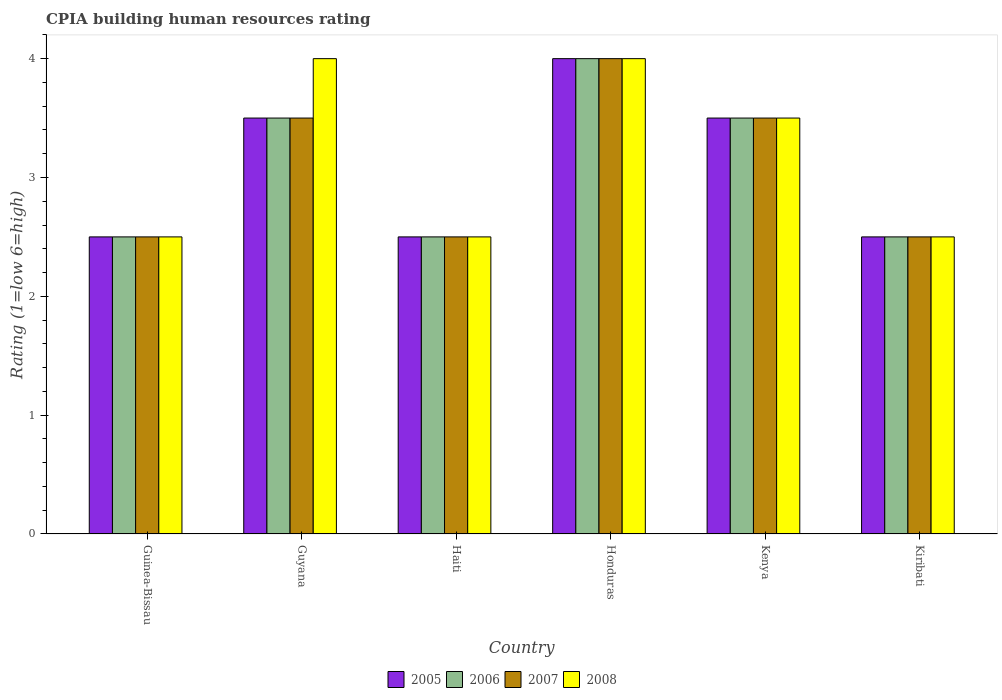How many different coloured bars are there?
Offer a terse response. 4. Are the number of bars per tick equal to the number of legend labels?
Your answer should be compact. Yes. How many bars are there on the 4th tick from the left?
Offer a terse response. 4. How many bars are there on the 5th tick from the right?
Ensure brevity in your answer.  4. What is the label of the 5th group of bars from the left?
Your response must be concise. Kenya. In how many cases, is the number of bars for a given country not equal to the number of legend labels?
Make the answer very short. 0. What is the CPIA rating in 2007 in Guyana?
Provide a succinct answer. 3.5. In which country was the CPIA rating in 2006 maximum?
Your response must be concise. Honduras. In which country was the CPIA rating in 2008 minimum?
Ensure brevity in your answer.  Guinea-Bissau. What is the difference between the CPIA rating in 2008 in Guyana and that in Kiribati?
Offer a very short reply. 1.5. What is the average CPIA rating in 2006 per country?
Ensure brevity in your answer.  3.08. What is the difference between the CPIA rating of/in 2005 and CPIA rating of/in 2007 in Honduras?
Give a very brief answer. 0. What is the ratio of the CPIA rating in 2006 in Guinea-Bissau to that in Haiti?
Offer a terse response. 1. Is the CPIA rating in 2008 in Honduras less than that in Kiribati?
Your response must be concise. No. Is the difference between the CPIA rating in 2005 in Guinea-Bissau and Honduras greater than the difference between the CPIA rating in 2007 in Guinea-Bissau and Honduras?
Offer a terse response. No. What is the difference between the highest and the second highest CPIA rating in 2007?
Give a very brief answer. -0.5. In how many countries, is the CPIA rating in 2008 greater than the average CPIA rating in 2008 taken over all countries?
Make the answer very short. 3. Is the sum of the CPIA rating in 2006 in Kenya and Kiribati greater than the maximum CPIA rating in 2005 across all countries?
Ensure brevity in your answer.  Yes. Is it the case that in every country, the sum of the CPIA rating in 2007 and CPIA rating in 2006 is greater than the sum of CPIA rating in 2005 and CPIA rating in 2008?
Keep it short and to the point. No. What does the 1st bar from the right in Haiti represents?
Make the answer very short. 2008. How many bars are there?
Your response must be concise. 24. Are all the bars in the graph horizontal?
Your response must be concise. No. What is the difference between two consecutive major ticks on the Y-axis?
Offer a very short reply. 1. Are the values on the major ticks of Y-axis written in scientific E-notation?
Offer a terse response. No. Does the graph contain grids?
Make the answer very short. No. Where does the legend appear in the graph?
Your response must be concise. Bottom center. What is the title of the graph?
Make the answer very short. CPIA building human resources rating. What is the label or title of the Y-axis?
Your response must be concise. Rating (1=low 6=high). What is the Rating (1=low 6=high) of 2005 in Guinea-Bissau?
Make the answer very short. 2.5. What is the Rating (1=low 6=high) of 2006 in Guinea-Bissau?
Provide a short and direct response. 2.5. What is the Rating (1=low 6=high) in 2007 in Guinea-Bissau?
Ensure brevity in your answer.  2.5. What is the Rating (1=low 6=high) of 2008 in Guinea-Bissau?
Offer a very short reply. 2.5. What is the Rating (1=low 6=high) in 2005 in Guyana?
Offer a terse response. 3.5. What is the Rating (1=low 6=high) of 2006 in Guyana?
Your response must be concise. 3.5. What is the Rating (1=low 6=high) of 2005 in Haiti?
Your answer should be compact. 2.5. What is the Rating (1=low 6=high) in 2007 in Honduras?
Provide a short and direct response. 4. What is the Rating (1=low 6=high) of 2008 in Honduras?
Keep it short and to the point. 4. What is the Rating (1=low 6=high) of 2005 in Kenya?
Give a very brief answer. 3.5. What is the Rating (1=low 6=high) in 2007 in Kenya?
Give a very brief answer. 3.5. What is the Rating (1=low 6=high) of 2005 in Kiribati?
Give a very brief answer. 2.5. Across all countries, what is the maximum Rating (1=low 6=high) in 2005?
Provide a short and direct response. 4. Across all countries, what is the minimum Rating (1=low 6=high) in 2005?
Offer a very short reply. 2.5. Across all countries, what is the minimum Rating (1=low 6=high) in 2007?
Your answer should be very brief. 2.5. What is the total Rating (1=low 6=high) in 2005 in the graph?
Provide a short and direct response. 18.5. What is the total Rating (1=low 6=high) in 2008 in the graph?
Offer a very short reply. 19. What is the difference between the Rating (1=low 6=high) of 2006 in Guinea-Bissau and that in Guyana?
Offer a very short reply. -1. What is the difference between the Rating (1=low 6=high) in 2008 in Guinea-Bissau and that in Guyana?
Ensure brevity in your answer.  -1.5. What is the difference between the Rating (1=low 6=high) in 2008 in Guinea-Bissau and that in Haiti?
Provide a succinct answer. 0. What is the difference between the Rating (1=low 6=high) of 2006 in Guinea-Bissau and that in Honduras?
Make the answer very short. -1.5. What is the difference between the Rating (1=low 6=high) of 2006 in Guinea-Bissau and that in Kenya?
Provide a short and direct response. -1. What is the difference between the Rating (1=low 6=high) of 2007 in Guinea-Bissau and that in Kenya?
Ensure brevity in your answer.  -1. What is the difference between the Rating (1=low 6=high) of 2008 in Guinea-Bissau and that in Kenya?
Make the answer very short. -1. What is the difference between the Rating (1=low 6=high) of 2005 in Guinea-Bissau and that in Kiribati?
Give a very brief answer. 0. What is the difference between the Rating (1=low 6=high) of 2006 in Guinea-Bissau and that in Kiribati?
Your answer should be compact. 0. What is the difference between the Rating (1=low 6=high) in 2006 in Guyana and that in Haiti?
Offer a very short reply. 1. What is the difference between the Rating (1=low 6=high) of 2007 in Guyana and that in Haiti?
Provide a short and direct response. 1. What is the difference between the Rating (1=low 6=high) of 2008 in Guyana and that in Haiti?
Offer a terse response. 1.5. What is the difference between the Rating (1=low 6=high) of 2005 in Guyana and that in Honduras?
Give a very brief answer. -0.5. What is the difference between the Rating (1=low 6=high) of 2006 in Guyana and that in Honduras?
Provide a short and direct response. -0.5. What is the difference between the Rating (1=low 6=high) of 2007 in Guyana and that in Honduras?
Offer a very short reply. -0.5. What is the difference between the Rating (1=low 6=high) of 2008 in Guyana and that in Honduras?
Your response must be concise. 0. What is the difference between the Rating (1=low 6=high) of 2007 in Guyana and that in Kenya?
Your answer should be very brief. 0. What is the difference between the Rating (1=low 6=high) in 2005 in Guyana and that in Kiribati?
Offer a terse response. 1. What is the difference between the Rating (1=low 6=high) in 2008 in Guyana and that in Kiribati?
Offer a very short reply. 1.5. What is the difference between the Rating (1=low 6=high) in 2005 in Haiti and that in Honduras?
Offer a terse response. -1.5. What is the difference between the Rating (1=low 6=high) in 2006 in Haiti and that in Honduras?
Ensure brevity in your answer.  -1.5. What is the difference between the Rating (1=low 6=high) of 2007 in Haiti and that in Honduras?
Give a very brief answer. -1.5. What is the difference between the Rating (1=low 6=high) in 2008 in Haiti and that in Honduras?
Offer a very short reply. -1.5. What is the difference between the Rating (1=low 6=high) of 2006 in Haiti and that in Kenya?
Offer a terse response. -1. What is the difference between the Rating (1=low 6=high) in 2008 in Haiti and that in Kenya?
Keep it short and to the point. -1. What is the difference between the Rating (1=low 6=high) in 2005 in Haiti and that in Kiribati?
Your answer should be compact. 0. What is the difference between the Rating (1=low 6=high) in 2008 in Haiti and that in Kiribati?
Make the answer very short. 0. What is the difference between the Rating (1=low 6=high) in 2005 in Honduras and that in Kenya?
Provide a succinct answer. 0.5. What is the difference between the Rating (1=low 6=high) in 2005 in Honduras and that in Kiribati?
Ensure brevity in your answer.  1.5. What is the difference between the Rating (1=low 6=high) in 2007 in Honduras and that in Kiribati?
Your answer should be compact. 1.5. What is the difference between the Rating (1=low 6=high) of 2007 in Guinea-Bissau and the Rating (1=low 6=high) of 2008 in Guyana?
Make the answer very short. -1.5. What is the difference between the Rating (1=low 6=high) in 2005 in Guinea-Bissau and the Rating (1=low 6=high) in 2006 in Haiti?
Provide a short and direct response. 0. What is the difference between the Rating (1=low 6=high) in 2006 in Guinea-Bissau and the Rating (1=low 6=high) in 2008 in Honduras?
Offer a very short reply. -1.5. What is the difference between the Rating (1=low 6=high) of 2007 in Guinea-Bissau and the Rating (1=low 6=high) of 2008 in Honduras?
Your response must be concise. -1.5. What is the difference between the Rating (1=low 6=high) in 2005 in Guinea-Bissau and the Rating (1=low 6=high) in 2007 in Kenya?
Keep it short and to the point. -1. What is the difference between the Rating (1=low 6=high) in 2005 in Guinea-Bissau and the Rating (1=low 6=high) in 2008 in Kenya?
Make the answer very short. -1. What is the difference between the Rating (1=low 6=high) of 2007 in Guinea-Bissau and the Rating (1=low 6=high) of 2008 in Kenya?
Offer a very short reply. -1. What is the difference between the Rating (1=low 6=high) in 2005 in Guinea-Bissau and the Rating (1=low 6=high) in 2006 in Kiribati?
Your answer should be compact. 0. What is the difference between the Rating (1=low 6=high) in 2006 in Guinea-Bissau and the Rating (1=low 6=high) in 2007 in Kiribati?
Your answer should be very brief. 0. What is the difference between the Rating (1=low 6=high) of 2007 in Guinea-Bissau and the Rating (1=low 6=high) of 2008 in Kiribati?
Ensure brevity in your answer.  0. What is the difference between the Rating (1=low 6=high) of 2005 in Guyana and the Rating (1=low 6=high) of 2007 in Haiti?
Keep it short and to the point. 1. What is the difference between the Rating (1=low 6=high) of 2005 in Guyana and the Rating (1=low 6=high) of 2008 in Haiti?
Provide a short and direct response. 1. What is the difference between the Rating (1=low 6=high) of 2006 in Guyana and the Rating (1=low 6=high) of 2007 in Haiti?
Give a very brief answer. 1. What is the difference between the Rating (1=low 6=high) in 2006 in Guyana and the Rating (1=low 6=high) in 2008 in Haiti?
Offer a very short reply. 1. What is the difference between the Rating (1=low 6=high) in 2007 in Guyana and the Rating (1=low 6=high) in 2008 in Haiti?
Ensure brevity in your answer.  1. What is the difference between the Rating (1=low 6=high) of 2005 in Guyana and the Rating (1=low 6=high) of 2006 in Honduras?
Keep it short and to the point. -0.5. What is the difference between the Rating (1=low 6=high) of 2005 in Guyana and the Rating (1=low 6=high) of 2007 in Honduras?
Your answer should be compact. -0.5. What is the difference between the Rating (1=low 6=high) of 2006 in Guyana and the Rating (1=low 6=high) of 2008 in Honduras?
Offer a very short reply. -0.5. What is the difference between the Rating (1=low 6=high) of 2007 in Guyana and the Rating (1=low 6=high) of 2008 in Honduras?
Make the answer very short. -0.5. What is the difference between the Rating (1=low 6=high) of 2005 in Guyana and the Rating (1=low 6=high) of 2006 in Kenya?
Make the answer very short. 0. What is the difference between the Rating (1=low 6=high) of 2005 in Guyana and the Rating (1=low 6=high) of 2007 in Kenya?
Provide a short and direct response. 0. What is the difference between the Rating (1=low 6=high) of 2006 in Guyana and the Rating (1=low 6=high) of 2007 in Kenya?
Your answer should be very brief. 0. What is the difference between the Rating (1=low 6=high) of 2006 in Guyana and the Rating (1=low 6=high) of 2008 in Kenya?
Ensure brevity in your answer.  0. What is the difference between the Rating (1=low 6=high) of 2005 in Guyana and the Rating (1=low 6=high) of 2006 in Kiribati?
Offer a very short reply. 1. What is the difference between the Rating (1=low 6=high) of 2005 in Guyana and the Rating (1=low 6=high) of 2007 in Kiribati?
Your answer should be very brief. 1. What is the difference between the Rating (1=low 6=high) of 2006 in Guyana and the Rating (1=low 6=high) of 2007 in Kiribati?
Your response must be concise. 1. What is the difference between the Rating (1=low 6=high) in 2005 in Haiti and the Rating (1=low 6=high) in 2007 in Honduras?
Offer a terse response. -1.5. What is the difference between the Rating (1=low 6=high) of 2005 in Haiti and the Rating (1=low 6=high) of 2008 in Honduras?
Your answer should be compact. -1.5. What is the difference between the Rating (1=low 6=high) of 2006 in Haiti and the Rating (1=low 6=high) of 2007 in Honduras?
Provide a succinct answer. -1.5. What is the difference between the Rating (1=low 6=high) of 2006 in Haiti and the Rating (1=low 6=high) of 2008 in Honduras?
Your answer should be compact. -1.5. What is the difference between the Rating (1=low 6=high) of 2007 in Haiti and the Rating (1=low 6=high) of 2008 in Honduras?
Keep it short and to the point. -1.5. What is the difference between the Rating (1=low 6=high) in 2005 in Haiti and the Rating (1=low 6=high) in 2006 in Kenya?
Offer a terse response. -1. What is the difference between the Rating (1=low 6=high) in 2005 in Haiti and the Rating (1=low 6=high) in 2007 in Kenya?
Offer a terse response. -1. What is the difference between the Rating (1=low 6=high) in 2007 in Haiti and the Rating (1=low 6=high) in 2008 in Kenya?
Ensure brevity in your answer.  -1. What is the difference between the Rating (1=low 6=high) of 2005 in Haiti and the Rating (1=low 6=high) of 2006 in Kiribati?
Provide a succinct answer. 0. What is the difference between the Rating (1=low 6=high) in 2005 in Haiti and the Rating (1=low 6=high) in 2007 in Kiribati?
Keep it short and to the point. 0. What is the difference between the Rating (1=low 6=high) of 2005 in Haiti and the Rating (1=low 6=high) of 2008 in Kiribati?
Your answer should be compact. 0. What is the difference between the Rating (1=low 6=high) in 2006 in Haiti and the Rating (1=low 6=high) in 2008 in Kiribati?
Provide a succinct answer. 0. What is the difference between the Rating (1=low 6=high) in 2007 in Haiti and the Rating (1=low 6=high) in 2008 in Kiribati?
Give a very brief answer. 0. What is the difference between the Rating (1=low 6=high) of 2005 in Honduras and the Rating (1=low 6=high) of 2006 in Kenya?
Ensure brevity in your answer.  0.5. What is the difference between the Rating (1=low 6=high) in 2005 in Honduras and the Rating (1=low 6=high) in 2007 in Kenya?
Give a very brief answer. 0.5. What is the difference between the Rating (1=low 6=high) of 2005 in Honduras and the Rating (1=low 6=high) of 2008 in Kenya?
Your answer should be very brief. 0.5. What is the difference between the Rating (1=low 6=high) of 2006 in Honduras and the Rating (1=low 6=high) of 2008 in Kenya?
Keep it short and to the point. 0.5. What is the difference between the Rating (1=low 6=high) in 2007 in Honduras and the Rating (1=low 6=high) in 2008 in Kenya?
Ensure brevity in your answer.  0.5. What is the difference between the Rating (1=low 6=high) of 2005 in Honduras and the Rating (1=low 6=high) of 2008 in Kiribati?
Provide a short and direct response. 1.5. What is the difference between the Rating (1=low 6=high) of 2006 in Honduras and the Rating (1=low 6=high) of 2007 in Kiribati?
Your response must be concise. 1.5. What is the difference between the Rating (1=low 6=high) of 2006 in Honduras and the Rating (1=low 6=high) of 2008 in Kiribati?
Provide a succinct answer. 1.5. What is the difference between the Rating (1=low 6=high) of 2007 in Honduras and the Rating (1=low 6=high) of 2008 in Kiribati?
Make the answer very short. 1.5. What is the difference between the Rating (1=low 6=high) of 2005 in Kenya and the Rating (1=low 6=high) of 2006 in Kiribati?
Provide a short and direct response. 1. What is the difference between the Rating (1=low 6=high) of 2005 in Kenya and the Rating (1=low 6=high) of 2007 in Kiribati?
Your response must be concise. 1. What is the difference between the Rating (1=low 6=high) of 2005 in Kenya and the Rating (1=low 6=high) of 2008 in Kiribati?
Provide a short and direct response. 1. What is the difference between the Rating (1=low 6=high) in 2006 in Kenya and the Rating (1=low 6=high) in 2007 in Kiribati?
Keep it short and to the point. 1. What is the difference between the Rating (1=low 6=high) of 2006 in Kenya and the Rating (1=low 6=high) of 2008 in Kiribati?
Make the answer very short. 1. What is the difference between the Rating (1=low 6=high) of 2007 in Kenya and the Rating (1=low 6=high) of 2008 in Kiribati?
Your answer should be compact. 1. What is the average Rating (1=low 6=high) in 2005 per country?
Give a very brief answer. 3.08. What is the average Rating (1=low 6=high) in 2006 per country?
Your answer should be very brief. 3.08. What is the average Rating (1=low 6=high) of 2007 per country?
Provide a succinct answer. 3.08. What is the average Rating (1=low 6=high) in 2008 per country?
Give a very brief answer. 3.17. What is the difference between the Rating (1=low 6=high) in 2006 and Rating (1=low 6=high) in 2008 in Guinea-Bissau?
Offer a terse response. 0. What is the difference between the Rating (1=low 6=high) in 2007 and Rating (1=low 6=high) in 2008 in Guinea-Bissau?
Give a very brief answer. 0. What is the difference between the Rating (1=low 6=high) in 2005 and Rating (1=low 6=high) in 2006 in Guyana?
Your response must be concise. 0. What is the difference between the Rating (1=low 6=high) in 2005 and Rating (1=low 6=high) in 2007 in Guyana?
Provide a short and direct response. 0. What is the difference between the Rating (1=low 6=high) of 2005 and Rating (1=low 6=high) of 2008 in Guyana?
Offer a terse response. -0.5. What is the difference between the Rating (1=low 6=high) in 2006 and Rating (1=low 6=high) in 2008 in Guyana?
Ensure brevity in your answer.  -0.5. What is the difference between the Rating (1=low 6=high) of 2005 and Rating (1=low 6=high) of 2007 in Haiti?
Make the answer very short. 0. What is the difference between the Rating (1=low 6=high) in 2005 and Rating (1=low 6=high) in 2008 in Haiti?
Offer a very short reply. 0. What is the difference between the Rating (1=low 6=high) of 2006 and Rating (1=low 6=high) of 2007 in Haiti?
Your answer should be very brief. 0. What is the difference between the Rating (1=low 6=high) of 2006 and Rating (1=low 6=high) of 2008 in Haiti?
Your answer should be compact. 0. What is the difference between the Rating (1=low 6=high) in 2005 and Rating (1=low 6=high) in 2006 in Honduras?
Make the answer very short. 0. What is the difference between the Rating (1=low 6=high) in 2005 and Rating (1=low 6=high) in 2008 in Honduras?
Ensure brevity in your answer.  0. What is the difference between the Rating (1=low 6=high) in 2006 and Rating (1=low 6=high) in 2008 in Honduras?
Provide a short and direct response. 0. What is the difference between the Rating (1=low 6=high) in 2005 and Rating (1=low 6=high) in 2007 in Kenya?
Ensure brevity in your answer.  0. What is the difference between the Rating (1=low 6=high) in 2005 and Rating (1=low 6=high) in 2008 in Kenya?
Offer a very short reply. 0. What is the difference between the Rating (1=low 6=high) of 2006 and Rating (1=low 6=high) of 2008 in Kenya?
Offer a terse response. 0. What is the difference between the Rating (1=low 6=high) in 2007 and Rating (1=low 6=high) in 2008 in Kenya?
Your response must be concise. 0. What is the difference between the Rating (1=low 6=high) in 2005 and Rating (1=low 6=high) in 2008 in Kiribati?
Offer a terse response. 0. What is the difference between the Rating (1=low 6=high) of 2006 and Rating (1=low 6=high) of 2007 in Kiribati?
Make the answer very short. 0. What is the difference between the Rating (1=low 6=high) of 2007 and Rating (1=low 6=high) of 2008 in Kiribati?
Your answer should be very brief. 0. What is the ratio of the Rating (1=low 6=high) of 2005 in Guinea-Bissau to that in Guyana?
Make the answer very short. 0.71. What is the ratio of the Rating (1=low 6=high) in 2007 in Guinea-Bissau to that in Guyana?
Ensure brevity in your answer.  0.71. What is the ratio of the Rating (1=low 6=high) in 2006 in Guinea-Bissau to that in Haiti?
Your answer should be very brief. 1. What is the ratio of the Rating (1=low 6=high) in 2007 in Guinea-Bissau to that in Haiti?
Offer a terse response. 1. What is the ratio of the Rating (1=low 6=high) in 2008 in Guinea-Bissau to that in Haiti?
Ensure brevity in your answer.  1. What is the ratio of the Rating (1=low 6=high) of 2006 in Guinea-Bissau to that in Honduras?
Provide a succinct answer. 0.62. What is the ratio of the Rating (1=low 6=high) of 2008 in Guinea-Bissau to that in Honduras?
Provide a succinct answer. 0.62. What is the ratio of the Rating (1=low 6=high) in 2007 in Guinea-Bissau to that in Kenya?
Make the answer very short. 0.71. What is the ratio of the Rating (1=low 6=high) of 2008 in Guinea-Bissau to that in Kenya?
Make the answer very short. 0.71. What is the ratio of the Rating (1=low 6=high) of 2005 in Guinea-Bissau to that in Kiribati?
Offer a very short reply. 1. What is the ratio of the Rating (1=low 6=high) in 2007 in Guinea-Bissau to that in Kiribati?
Ensure brevity in your answer.  1. What is the ratio of the Rating (1=low 6=high) in 2008 in Guinea-Bissau to that in Kiribati?
Provide a short and direct response. 1. What is the ratio of the Rating (1=low 6=high) of 2006 in Guyana to that in Haiti?
Offer a terse response. 1.4. What is the ratio of the Rating (1=low 6=high) of 2005 in Guyana to that in Honduras?
Provide a succinct answer. 0.88. What is the ratio of the Rating (1=low 6=high) in 2008 in Guyana to that in Honduras?
Your response must be concise. 1. What is the ratio of the Rating (1=low 6=high) of 2007 in Guyana to that in Kenya?
Make the answer very short. 1. What is the ratio of the Rating (1=low 6=high) of 2008 in Guyana to that in Kenya?
Ensure brevity in your answer.  1.14. What is the ratio of the Rating (1=low 6=high) of 2006 in Guyana to that in Kiribati?
Ensure brevity in your answer.  1.4. What is the ratio of the Rating (1=low 6=high) in 2008 in Guyana to that in Kiribati?
Provide a succinct answer. 1.6. What is the ratio of the Rating (1=low 6=high) of 2005 in Haiti to that in Honduras?
Provide a short and direct response. 0.62. What is the ratio of the Rating (1=low 6=high) of 2007 in Haiti to that in Honduras?
Make the answer very short. 0.62. What is the ratio of the Rating (1=low 6=high) of 2008 in Haiti to that in Honduras?
Your response must be concise. 0.62. What is the ratio of the Rating (1=low 6=high) in 2006 in Haiti to that in Kenya?
Make the answer very short. 0.71. What is the ratio of the Rating (1=low 6=high) in 2007 in Haiti to that in Kenya?
Give a very brief answer. 0.71. What is the ratio of the Rating (1=low 6=high) in 2006 in Haiti to that in Kiribati?
Ensure brevity in your answer.  1. What is the ratio of the Rating (1=low 6=high) of 2007 in Haiti to that in Kiribati?
Ensure brevity in your answer.  1. What is the ratio of the Rating (1=low 6=high) in 2008 in Haiti to that in Kiribati?
Your response must be concise. 1. What is the ratio of the Rating (1=low 6=high) of 2005 in Honduras to that in Kenya?
Offer a terse response. 1.14. What is the ratio of the Rating (1=low 6=high) in 2008 in Honduras to that in Kenya?
Give a very brief answer. 1.14. What is the ratio of the Rating (1=low 6=high) in 2007 in Honduras to that in Kiribati?
Give a very brief answer. 1.6. What is the difference between the highest and the second highest Rating (1=low 6=high) of 2005?
Your answer should be very brief. 0.5. What is the difference between the highest and the second highest Rating (1=low 6=high) of 2007?
Your answer should be very brief. 0.5. What is the difference between the highest and the second highest Rating (1=low 6=high) in 2008?
Provide a succinct answer. 0. What is the difference between the highest and the lowest Rating (1=low 6=high) of 2007?
Give a very brief answer. 1.5. What is the difference between the highest and the lowest Rating (1=low 6=high) in 2008?
Ensure brevity in your answer.  1.5. 